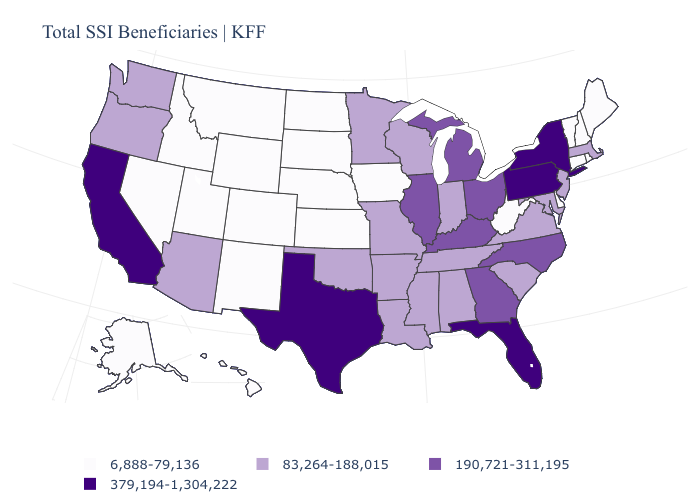What is the value of Pennsylvania?
Keep it brief. 379,194-1,304,222. Does the first symbol in the legend represent the smallest category?
Keep it brief. Yes. Does Tennessee have the highest value in the USA?
Keep it brief. No. Among the states that border Delaware , does New Jersey have the highest value?
Be succinct. No. Does Arizona have the same value as Iowa?
Keep it brief. No. Which states have the lowest value in the USA?
Keep it brief. Alaska, Colorado, Connecticut, Delaware, Hawaii, Idaho, Iowa, Kansas, Maine, Montana, Nebraska, Nevada, New Hampshire, New Mexico, North Dakota, Rhode Island, South Dakota, Utah, Vermont, West Virginia, Wyoming. Name the states that have a value in the range 6,888-79,136?
Answer briefly. Alaska, Colorado, Connecticut, Delaware, Hawaii, Idaho, Iowa, Kansas, Maine, Montana, Nebraska, Nevada, New Hampshire, New Mexico, North Dakota, Rhode Island, South Dakota, Utah, Vermont, West Virginia, Wyoming. Does Florida have the highest value in the South?
Short answer required. Yes. Name the states that have a value in the range 83,264-188,015?
Be succinct. Alabama, Arizona, Arkansas, Indiana, Louisiana, Maryland, Massachusetts, Minnesota, Mississippi, Missouri, New Jersey, Oklahoma, Oregon, South Carolina, Tennessee, Virginia, Washington, Wisconsin. What is the lowest value in the MidWest?
Keep it brief. 6,888-79,136. Among the states that border Maine , which have the lowest value?
Quick response, please. New Hampshire. What is the lowest value in states that border South Carolina?
Keep it brief. 190,721-311,195. Name the states that have a value in the range 83,264-188,015?
Answer briefly. Alabama, Arizona, Arkansas, Indiana, Louisiana, Maryland, Massachusetts, Minnesota, Mississippi, Missouri, New Jersey, Oklahoma, Oregon, South Carolina, Tennessee, Virginia, Washington, Wisconsin. Name the states that have a value in the range 6,888-79,136?
Give a very brief answer. Alaska, Colorado, Connecticut, Delaware, Hawaii, Idaho, Iowa, Kansas, Maine, Montana, Nebraska, Nevada, New Hampshire, New Mexico, North Dakota, Rhode Island, South Dakota, Utah, Vermont, West Virginia, Wyoming. 